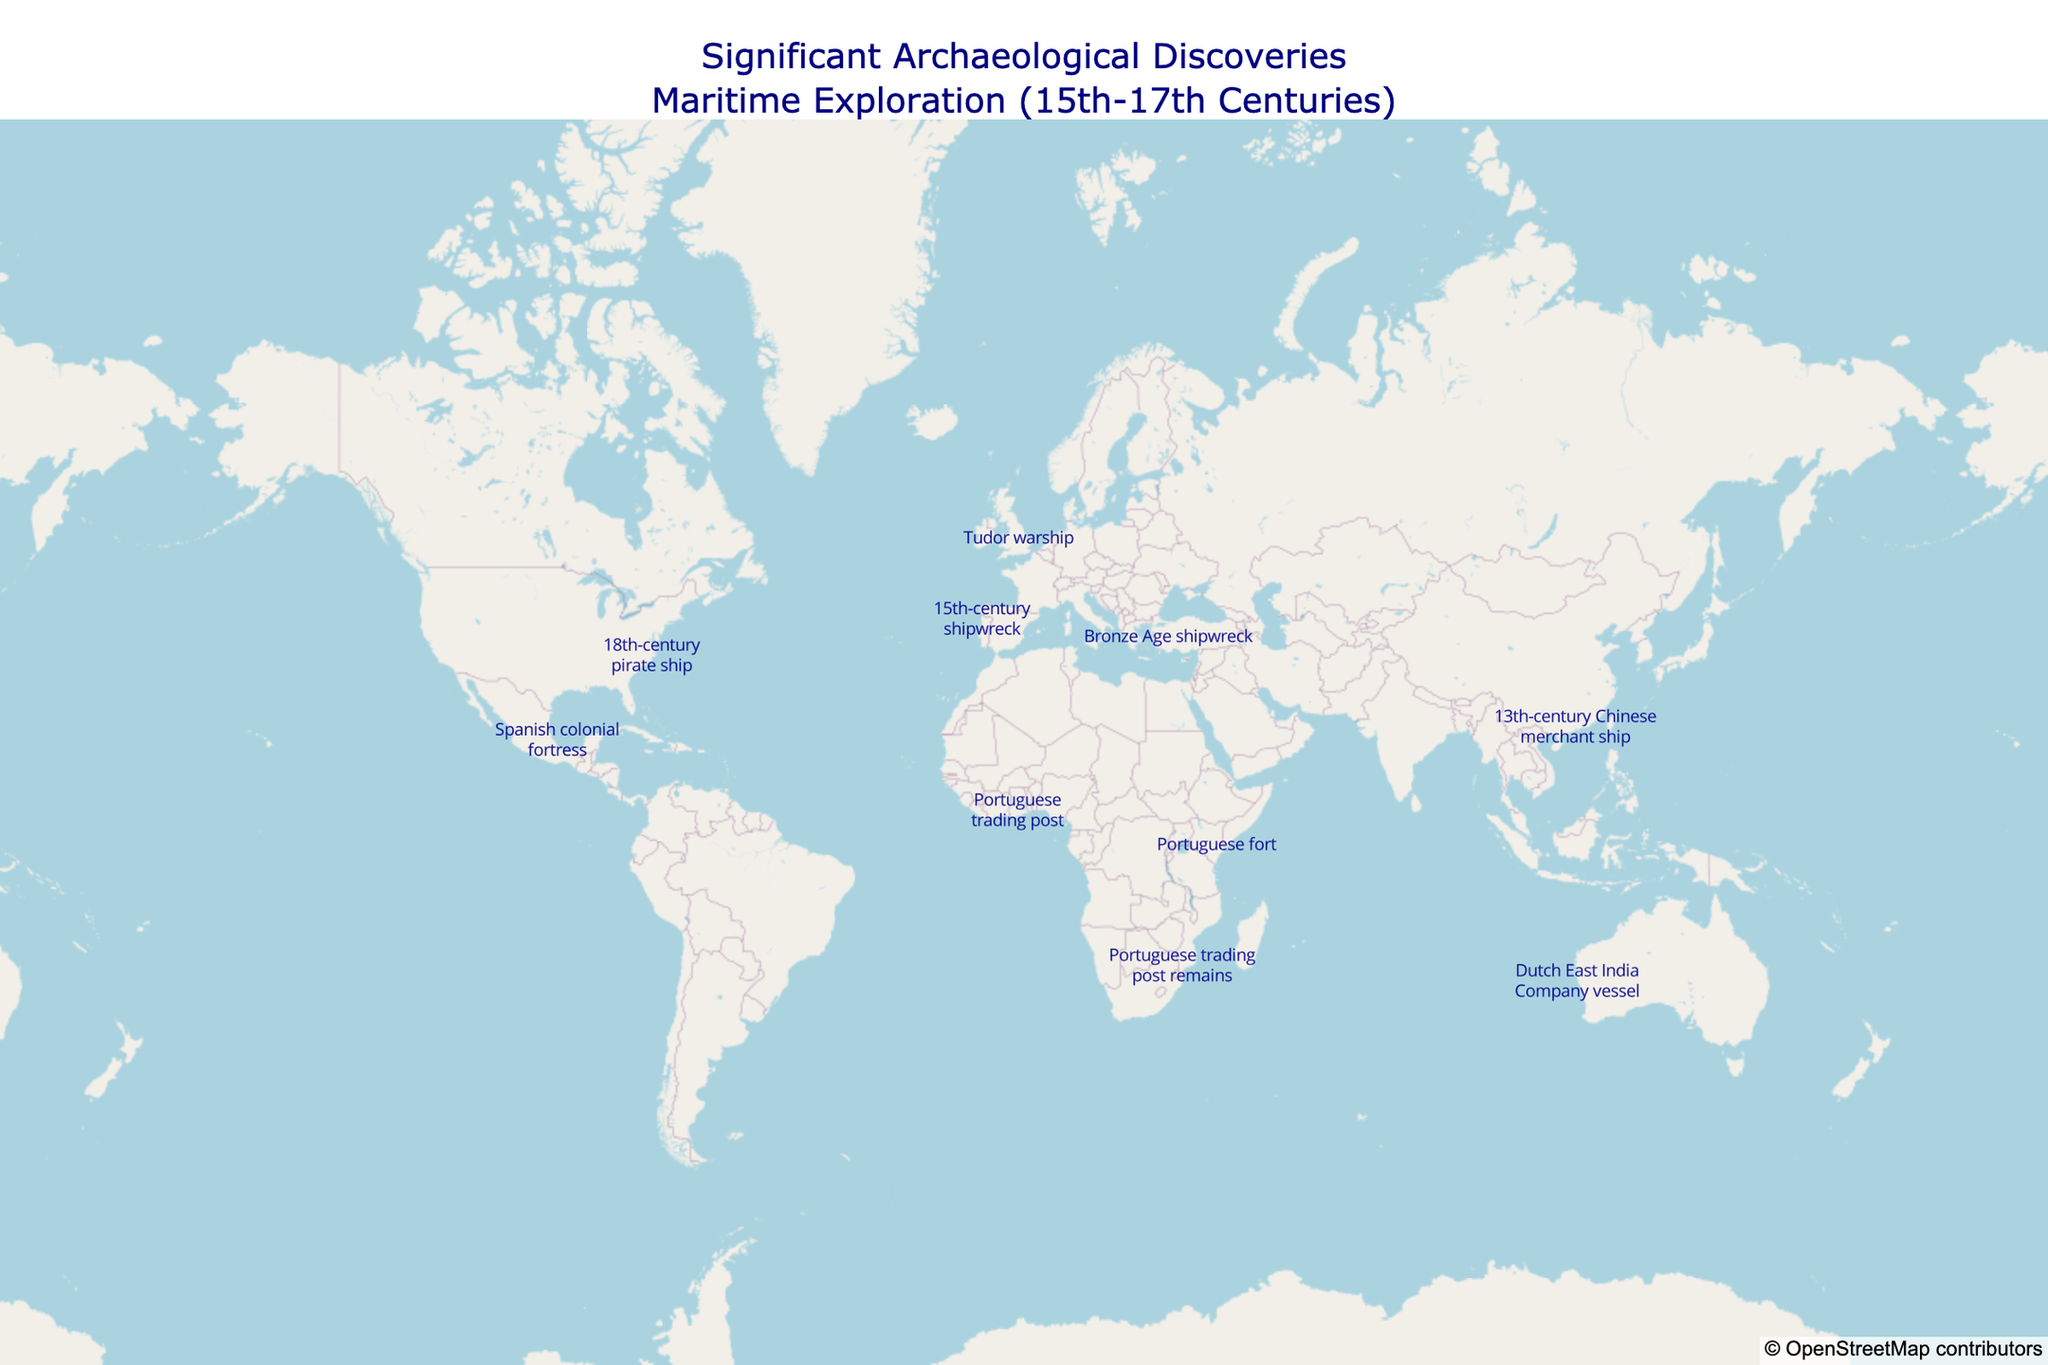What is the title of the map? The title of the map is displayed prominently at the top center. It indicates the theme of the plot: "Significant Archaeological Discoveries<br>Maritime Exploration (15th-17th Centuries)."
Answer: Significant Archaeological Discoveries<br>Maritime Exploration (15th-17th Centuries) How many locations are marked on the map? By counting the number of markers on the map, we can determine how many locations are presented. There are a total of 12 markers on the map.
Answer: 12 Which archaeological discovery is located furthest North? By examining the latitude coordinates of each marked location on the map, we identify that the Kronan Wreck (located at 56.4472) is the furthest North.
Answer: Kronan Wreck What discovery is near the coordinates 19.2083 latitude and -96.1333 longitude? By identifying the marker closest to the given coordinates on the map, we see that it is the Spanish colonial fortress, San Juan de Ulúa.
Answer: San Juan de Ulúa Which discovery is associated with the earliest year on the map? To find the earliest year, locate the marker with the smallest year value. The Portuguese trading post at Elmina Castle, discovered in 1482, has the earliest year on the map.
Answer: Elmina Castle, 1482 Which discoveries are located in the Southern Hemisphere? By looking at the coordinates with negative latitudes, the discoveries in the Southern Hemisphere include the Vasco da Gama Site, Batavia Shipwreck, Fort Jesus, and Madre de Deus Wreck.
Answer: Vasco da Gama Site, Batavia Shipwreck, Fort Jesus, Madre de Deus Wreck How many Portuguese-related discoveries are marked on the map? By identifying locations associated with Portuguese discoveries, we see the Vasco da Gama Site, Elmina Castle, Fort Jesus, and Madre de Deus Wreck, totaling four discoveries.
Answer: 4 What is the average latitude of all the locations? To calculate the average latitude, sum all the latitude values and divide by the number of locations: (36.1333 + (-25.9667) + 56.4472 + 50.7697 + (-28.7953) + 34.6956 + 19.2083 + (-4.0619) + 5.0847 + 40.6389 + 21.7500 + (-5.5247)) / 12 = 16.07305.
Answer: 16.07305 Which discovery has the closest proximity to the equator? The discovery closest to the equator will have the latitude closest to 0. By comparing the latitude values, Fort Jesus at -4.0619 latitude is the closest to the equator.
Answer: Fort Jesus What additional information is available when you hover over a marker? Hovering over a marker reveals detailed information including the name of the discovery, the location, and the year of the discovery.
Answer: Name, location, and year 